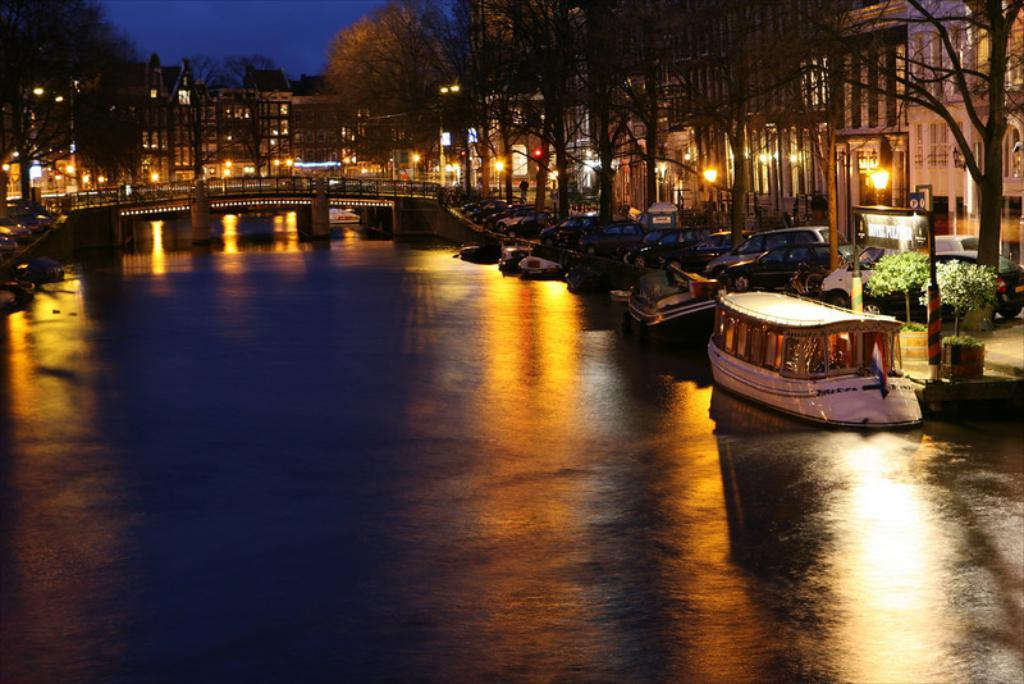What is located in the middle of the image? There is water in the middle of the image. What can be seen floating on the water? There are boats parked in the water. What type of vegetation is on the right side of the image? There are trees on the right side of the image. What structures are visible on the right side of the image? There are buildings with lights on the right side of the image. What type of coil is used to create the design of the boats in the image? There is no mention of a coil or any specific design element in the image. The boats are simply parked in the water. 